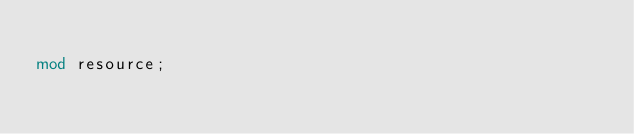<code> <loc_0><loc_0><loc_500><loc_500><_Rust_>
mod resource;
</code> 